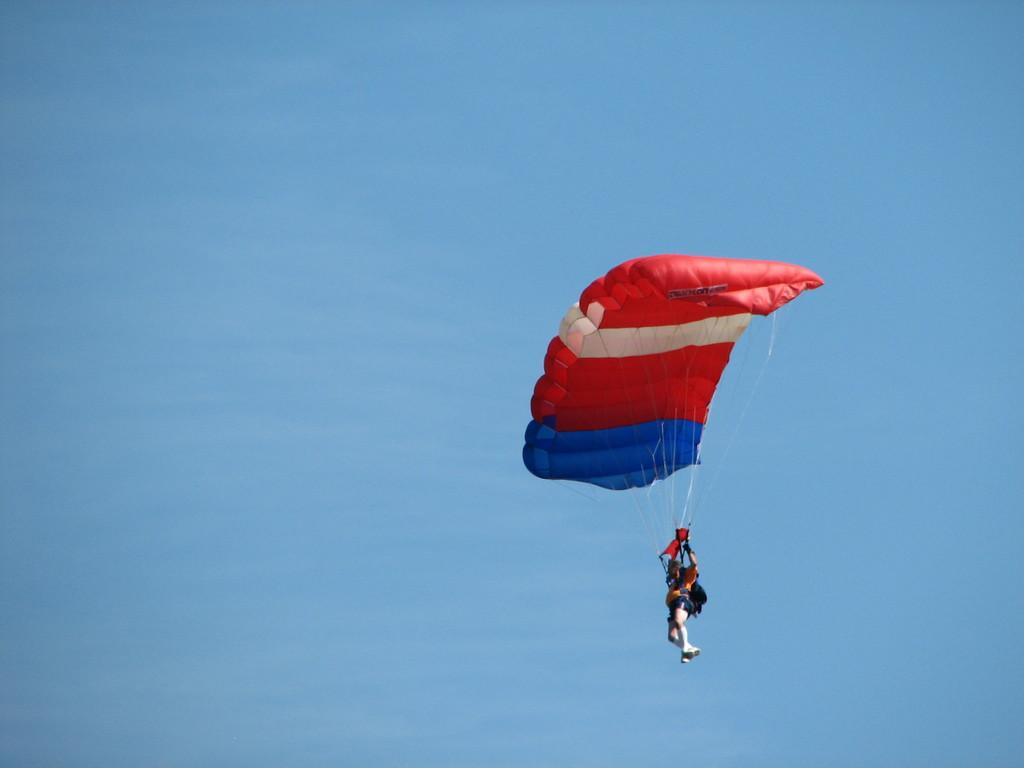Who or what is the main subject in the image? There is a person in the image. What is the person wearing in the image? The person is wearing a parachute in the image. Where is the person located in the image? The person is in the center of the image. How many apples can be seen in the image? There are no apples present in the image. What type of children are playing in the image? There are no children present in the image. 